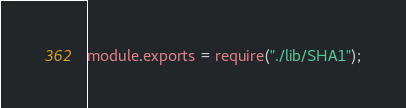<code> <loc_0><loc_0><loc_500><loc_500><_JavaScript_>module.exports = require("./lib/SHA1");

</code> 